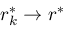<formula> <loc_0><loc_0><loc_500><loc_500>r _ { k } ^ { \ast } \to r ^ { \ast }</formula> 